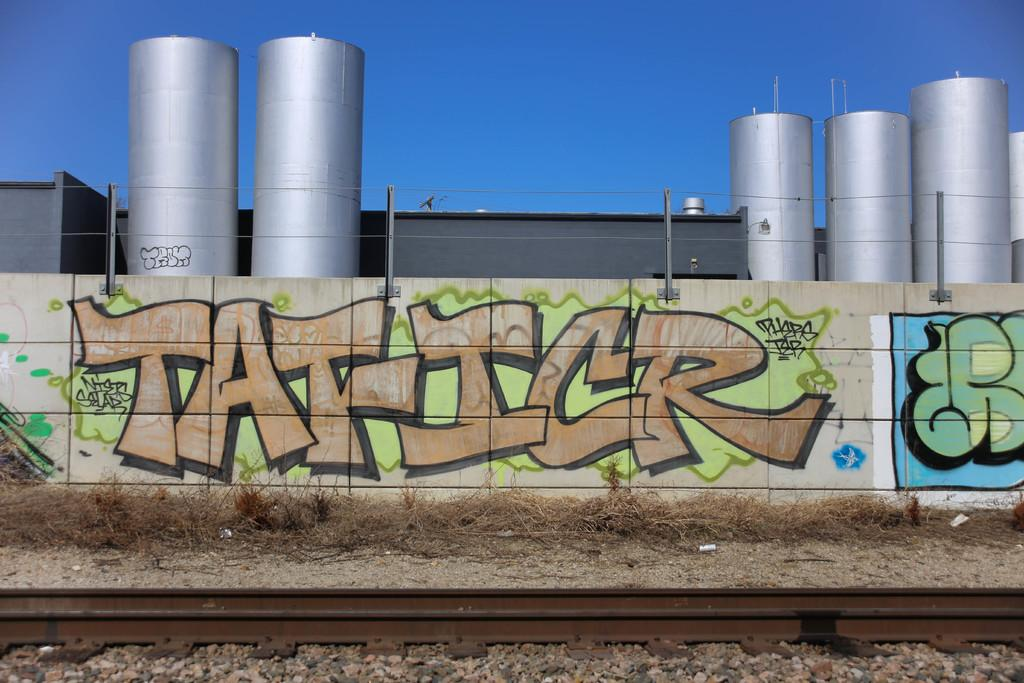<image>
Summarize the visual content of the image. A stone wall has the word "Taficr" written on it, in a graffiti style. 